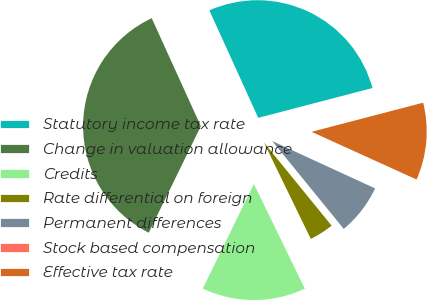Convert chart to OTSL. <chart><loc_0><loc_0><loc_500><loc_500><pie_chart><fcel>Statutory income tax rate<fcel>Change in valuation allowance<fcel>Credits<fcel>Rate differential on foreign<fcel>Permanent differences<fcel>Stock based compensation<fcel>Effective tax rate<nl><fcel>27.73%<fcel>35.97%<fcel>14.44%<fcel>3.67%<fcel>7.26%<fcel>0.08%<fcel>10.85%<nl></chart> 